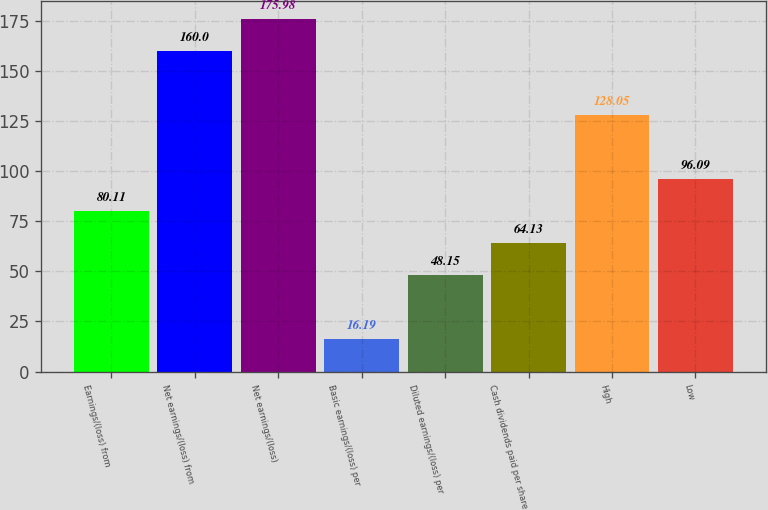<chart> <loc_0><loc_0><loc_500><loc_500><bar_chart><fcel>Earnings/(loss) from<fcel>Net earnings/(loss) from<fcel>Net earnings/(loss)<fcel>Basic earnings/(loss) per<fcel>Diluted earnings/(loss) per<fcel>Cash dividends paid per share<fcel>High<fcel>Low<nl><fcel>80.11<fcel>160<fcel>175.98<fcel>16.19<fcel>48.15<fcel>64.13<fcel>128.05<fcel>96.09<nl></chart> 